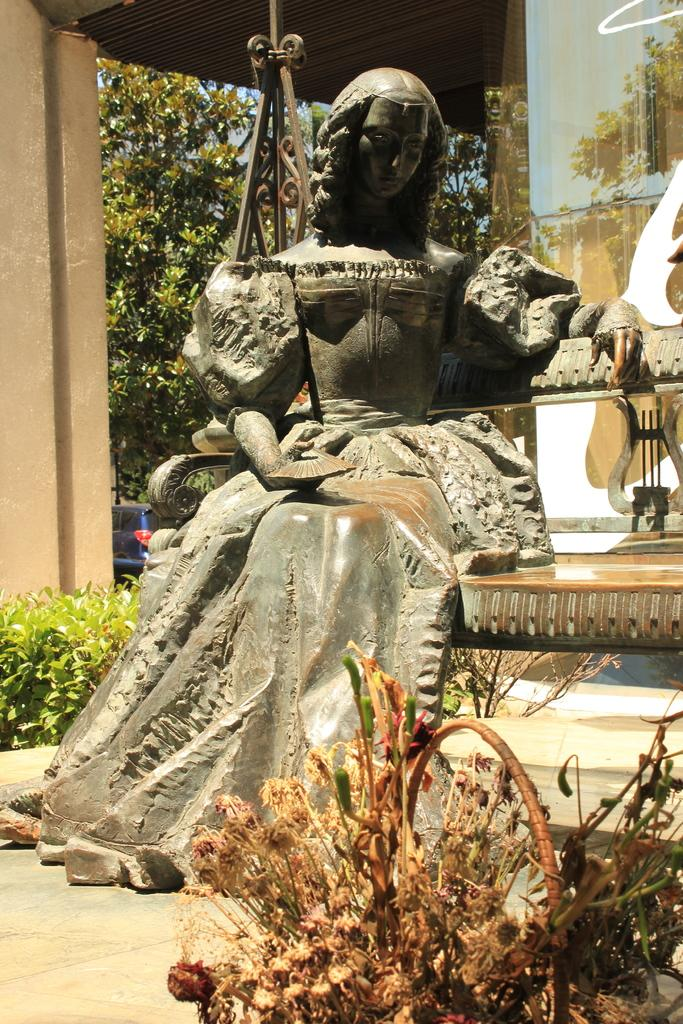What is the main subject of the image? There is a statue of a woman in the image. What other objects or elements can be seen in the image? There are plants, a basket, a bench, a pillar, a wall, rods, a roof, and some objects in the image. Additionally, there are trees in the background. Can you describe the setting or environment of the image? The image appears to be set in an outdoor area with plants, trees, and architectural elements such as a pillar, wall, and roof. Can you see any sea creatures swimming around the statue in the image? There is no sea or sea creatures present in the image; it features a statue of a woman in an outdoor setting with plants, trees, and architectural elements. 